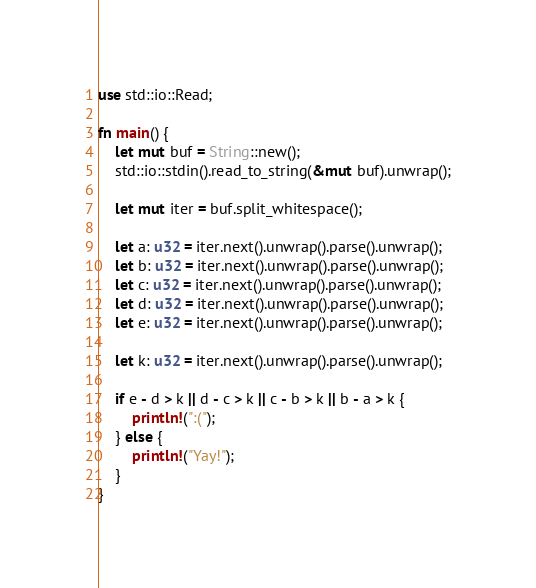Convert code to text. <code><loc_0><loc_0><loc_500><loc_500><_Rust_>use std::io::Read;

fn main() {
    let mut buf = String::new();
    std::io::stdin().read_to_string(&mut buf).unwrap();
    
    let mut iter = buf.split_whitespace();
    
    let a: u32 = iter.next().unwrap().parse().unwrap();
    let b: u32 = iter.next().unwrap().parse().unwrap();
    let c: u32 = iter.next().unwrap().parse().unwrap();
    let d: u32 = iter.next().unwrap().parse().unwrap();
    let e: u32 = iter.next().unwrap().parse().unwrap();
    
    let k: u32 = iter.next().unwrap().parse().unwrap();
    
    if e - d > k || d - c > k || c - b > k || b - a > k {
        println!(":(");
    } else {
        println!("Yay!");
    }
}</code> 